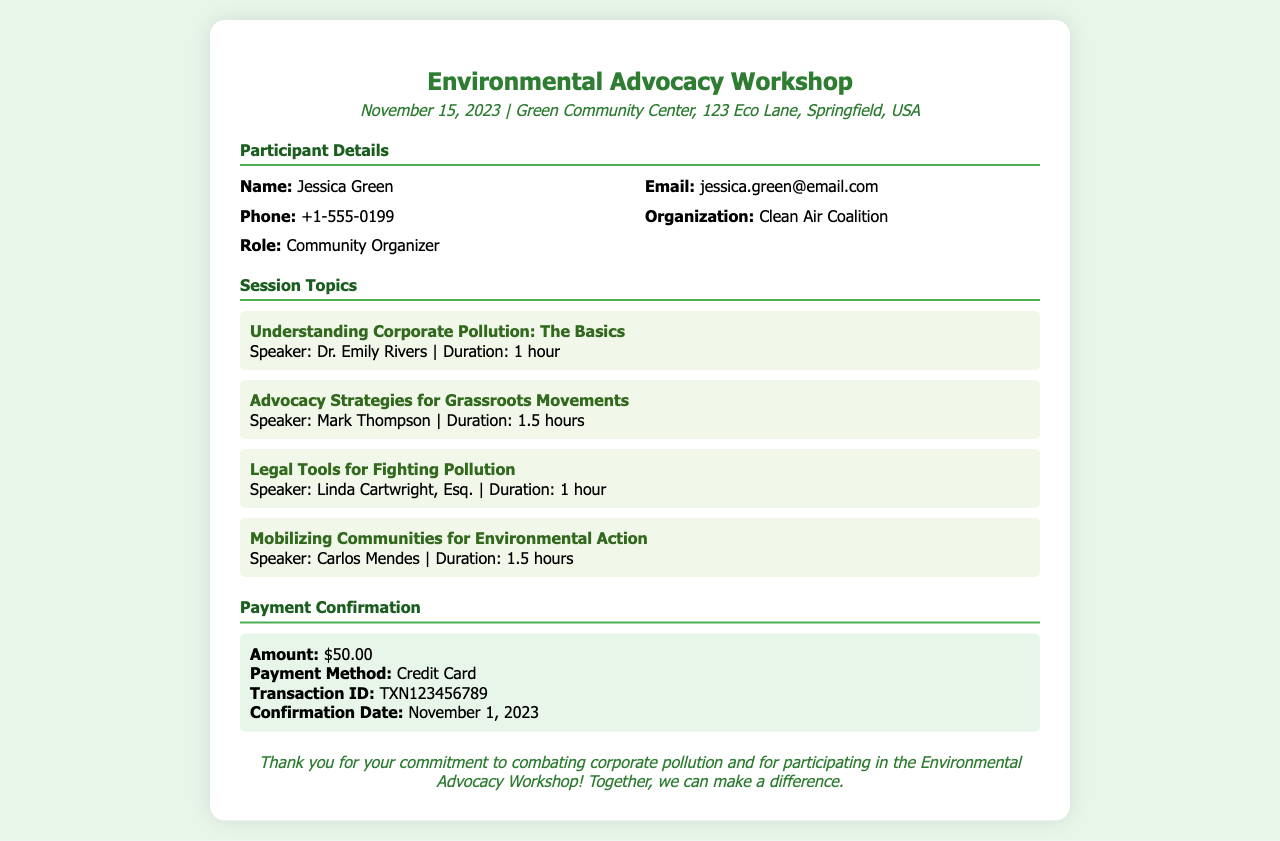What is the event date? The event date is explicitly stated in the document under the event details section.
Answer: November 15, 2023 Who is the participant listed? The participant's name is highlighted in the participant details section of the document.
Answer: Jessica Green What organization does the participant belong to? The participant's organization is provided in the participant details section.
Answer: Clean Air Coalition What is the duration of the session on "Mobilizing Communities for Environmental Action"? The duration is given next to the session title in the document.
Answer: 1.5 hours How much was the payment made? The payment amount is clearly stated in the payment confirmation section of the document.
Answer: $50.00 What payment method was used? The payment method is mentioned in the payment confirmation section.
Answer: Credit Card Who is the speaker for the session on "Legal Tools for Fighting Pollution"? The speaker's name is included in the session topics section next to the session title.
Answer: Linda Cartwright, Esq What is the transaction ID? The transaction ID is provided in the payment confirmation subsection.
Answer: TXN123456789 How many sessions are listed in the document? The total number of sessions can be counted from the session topics section.
Answer: 4 